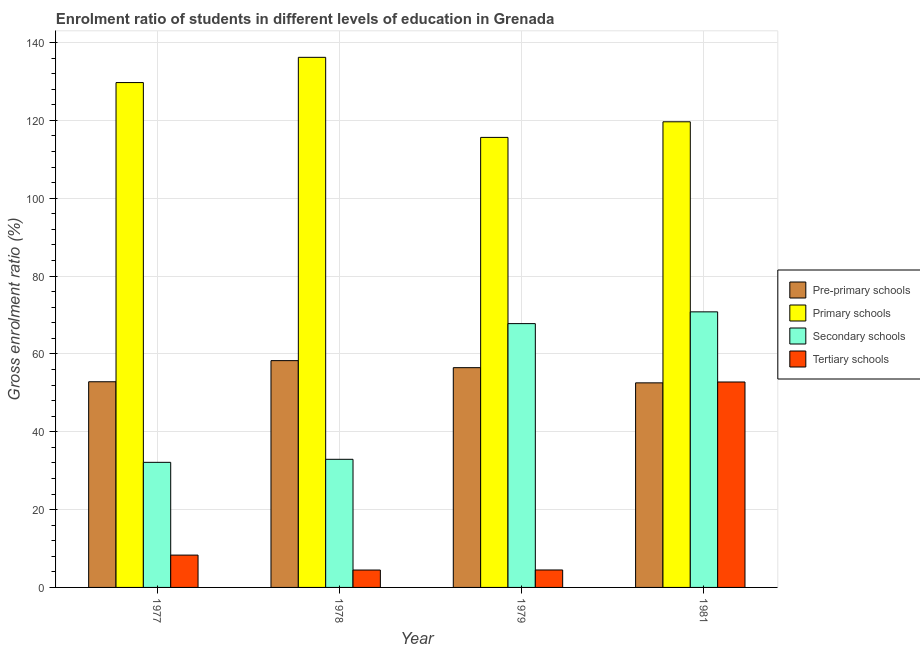Are the number of bars per tick equal to the number of legend labels?
Ensure brevity in your answer.  Yes. Are the number of bars on each tick of the X-axis equal?
Keep it short and to the point. Yes. What is the label of the 4th group of bars from the left?
Provide a succinct answer. 1981. What is the gross enrolment ratio in primary schools in 1981?
Ensure brevity in your answer.  119.62. Across all years, what is the maximum gross enrolment ratio in primary schools?
Provide a short and direct response. 136.18. Across all years, what is the minimum gross enrolment ratio in secondary schools?
Your response must be concise. 32.13. In which year was the gross enrolment ratio in primary schools maximum?
Provide a short and direct response. 1978. In which year was the gross enrolment ratio in primary schools minimum?
Your answer should be very brief. 1979. What is the total gross enrolment ratio in tertiary schools in the graph?
Offer a terse response. 70.02. What is the difference between the gross enrolment ratio in tertiary schools in 1978 and that in 1979?
Provide a short and direct response. -0.02. What is the difference between the gross enrolment ratio in primary schools in 1979 and the gross enrolment ratio in tertiary schools in 1981?
Your response must be concise. -4.01. What is the average gross enrolment ratio in primary schools per year?
Your answer should be compact. 125.27. In the year 1978, what is the difference between the gross enrolment ratio in tertiary schools and gross enrolment ratio in pre-primary schools?
Offer a terse response. 0. What is the ratio of the gross enrolment ratio in secondary schools in 1978 to that in 1979?
Make the answer very short. 0.49. Is the gross enrolment ratio in secondary schools in 1978 less than that in 1981?
Keep it short and to the point. Yes. Is the difference between the gross enrolment ratio in pre-primary schools in 1979 and 1981 greater than the difference between the gross enrolment ratio in primary schools in 1979 and 1981?
Provide a short and direct response. No. What is the difference between the highest and the second highest gross enrolment ratio in tertiary schools?
Your answer should be very brief. 44.47. What is the difference between the highest and the lowest gross enrolment ratio in tertiary schools?
Your answer should be compact. 48.31. Is the sum of the gross enrolment ratio in secondary schools in 1977 and 1981 greater than the maximum gross enrolment ratio in tertiary schools across all years?
Your answer should be compact. Yes. Is it the case that in every year, the sum of the gross enrolment ratio in tertiary schools and gross enrolment ratio in primary schools is greater than the sum of gross enrolment ratio in pre-primary schools and gross enrolment ratio in secondary schools?
Make the answer very short. No. What does the 3rd bar from the left in 1979 represents?
Provide a succinct answer. Secondary schools. What does the 3rd bar from the right in 1981 represents?
Provide a succinct answer. Primary schools. Are all the bars in the graph horizontal?
Offer a terse response. No. How many years are there in the graph?
Keep it short and to the point. 4. What is the difference between two consecutive major ticks on the Y-axis?
Offer a terse response. 20. Are the values on the major ticks of Y-axis written in scientific E-notation?
Offer a terse response. No. Does the graph contain grids?
Make the answer very short. Yes. Where does the legend appear in the graph?
Make the answer very short. Center right. What is the title of the graph?
Offer a very short reply. Enrolment ratio of students in different levels of education in Grenada. What is the label or title of the X-axis?
Give a very brief answer. Year. What is the Gross enrolment ratio (%) in Pre-primary schools in 1977?
Make the answer very short. 52.84. What is the Gross enrolment ratio (%) in Primary schools in 1977?
Offer a terse response. 129.69. What is the Gross enrolment ratio (%) of Secondary schools in 1977?
Make the answer very short. 32.13. What is the Gross enrolment ratio (%) of Tertiary schools in 1977?
Provide a short and direct response. 8.3. What is the Gross enrolment ratio (%) of Pre-primary schools in 1978?
Make the answer very short. 58.26. What is the Gross enrolment ratio (%) in Primary schools in 1978?
Offer a very short reply. 136.18. What is the Gross enrolment ratio (%) of Secondary schools in 1978?
Make the answer very short. 32.91. What is the Gross enrolment ratio (%) of Tertiary schools in 1978?
Your answer should be compact. 4.47. What is the Gross enrolment ratio (%) in Pre-primary schools in 1979?
Your answer should be very brief. 56.45. What is the Gross enrolment ratio (%) in Primary schools in 1979?
Your response must be concise. 115.61. What is the Gross enrolment ratio (%) of Secondary schools in 1979?
Your response must be concise. 67.77. What is the Gross enrolment ratio (%) of Tertiary schools in 1979?
Make the answer very short. 4.48. What is the Gross enrolment ratio (%) in Pre-primary schools in 1981?
Offer a very short reply. 52.55. What is the Gross enrolment ratio (%) in Primary schools in 1981?
Keep it short and to the point. 119.62. What is the Gross enrolment ratio (%) in Secondary schools in 1981?
Give a very brief answer. 70.79. What is the Gross enrolment ratio (%) of Tertiary schools in 1981?
Your answer should be very brief. 52.77. Across all years, what is the maximum Gross enrolment ratio (%) in Pre-primary schools?
Offer a very short reply. 58.26. Across all years, what is the maximum Gross enrolment ratio (%) in Primary schools?
Offer a very short reply. 136.18. Across all years, what is the maximum Gross enrolment ratio (%) in Secondary schools?
Your answer should be very brief. 70.79. Across all years, what is the maximum Gross enrolment ratio (%) in Tertiary schools?
Provide a succinct answer. 52.77. Across all years, what is the minimum Gross enrolment ratio (%) in Pre-primary schools?
Your response must be concise. 52.55. Across all years, what is the minimum Gross enrolment ratio (%) of Primary schools?
Ensure brevity in your answer.  115.61. Across all years, what is the minimum Gross enrolment ratio (%) of Secondary schools?
Keep it short and to the point. 32.13. Across all years, what is the minimum Gross enrolment ratio (%) of Tertiary schools?
Give a very brief answer. 4.47. What is the total Gross enrolment ratio (%) of Pre-primary schools in the graph?
Offer a terse response. 220.1. What is the total Gross enrolment ratio (%) of Primary schools in the graph?
Offer a terse response. 501.1. What is the total Gross enrolment ratio (%) in Secondary schools in the graph?
Give a very brief answer. 203.61. What is the total Gross enrolment ratio (%) in Tertiary schools in the graph?
Provide a short and direct response. 70.02. What is the difference between the Gross enrolment ratio (%) of Pre-primary schools in 1977 and that in 1978?
Give a very brief answer. -5.42. What is the difference between the Gross enrolment ratio (%) of Primary schools in 1977 and that in 1978?
Provide a short and direct response. -6.49. What is the difference between the Gross enrolment ratio (%) of Secondary schools in 1977 and that in 1978?
Offer a very short reply. -0.78. What is the difference between the Gross enrolment ratio (%) in Tertiary schools in 1977 and that in 1978?
Keep it short and to the point. 3.84. What is the difference between the Gross enrolment ratio (%) in Pre-primary schools in 1977 and that in 1979?
Make the answer very short. -3.62. What is the difference between the Gross enrolment ratio (%) in Primary schools in 1977 and that in 1979?
Your answer should be very brief. 14.08. What is the difference between the Gross enrolment ratio (%) of Secondary schools in 1977 and that in 1979?
Ensure brevity in your answer.  -35.63. What is the difference between the Gross enrolment ratio (%) in Tertiary schools in 1977 and that in 1979?
Ensure brevity in your answer.  3.82. What is the difference between the Gross enrolment ratio (%) of Pre-primary schools in 1977 and that in 1981?
Keep it short and to the point. 0.28. What is the difference between the Gross enrolment ratio (%) in Primary schools in 1977 and that in 1981?
Give a very brief answer. 10.07. What is the difference between the Gross enrolment ratio (%) in Secondary schools in 1977 and that in 1981?
Offer a very short reply. -38.66. What is the difference between the Gross enrolment ratio (%) of Tertiary schools in 1977 and that in 1981?
Your answer should be very brief. -44.47. What is the difference between the Gross enrolment ratio (%) of Pre-primary schools in 1978 and that in 1979?
Provide a short and direct response. 1.81. What is the difference between the Gross enrolment ratio (%) in Primary schools in 1978 and that in 1979?
Offer a very short reply. 20.57. What is the difference between the Gross enrolment ratio (%) in Secondary schools in 1978 and that in 1979?
Provide a short and direct response. -34.86. What is the difference between the Gross enrolment ratio (%) in Tertiary schools in 1978 and that in 1979?
Offer a very short reply. -0.02. What is the difference between the Gross enrolment ratio (%) of Pre-primary schools in 1978 and that in 1981?
Ensure brevity in your answer.  5.71. What is the difference between the Gross enrolment ratio (%) in Primary schools in 1978 and that in 1981?
Your answer should be compact. 16.56. What is the difference between the Gross enrolment ratio (%) of Secondary schools in 1978 and that in 1981?
Your answer should be compact. -37.88. What is the difference between the Gross enrolment ratio (%) in Tertiary schools in 1978 and that in 1981?
Make the answer very short. -48.31. What is the difference between the Gross enrolment ratio (%) of Primary schools in 1979 and that in 1981?
Give a very brief answer. -4.01. What is the difference between the Gross enrolment ratio (%) of Secondary schools in 1979 and that in 1981?
Offer a terse response. -3.02. What is the difference between the Gross enrolment ratio (%) of Tertiary schools in 1979 and that in 1981?
Give a very brief answer. -48.29. What is the difference between the Gross enrolment ratio (%) in Pre-primary schools in 1977 and the Gross enrolment ratio (%) in Primary schools in 1978?
Your answer should be very brief. -83.34. What is the difference between the Gross enrolment ratio (%) of Pre-primary schools in 1977 and the Gross enrolment ratio (%) of Secondary schools in 1978?
Your response must be concise. 19.92. What is the difference between the Gross enrolment ratio (%) of Pre-primary schools in 1977 and the Gross enrolment ratio (%) of Tertiary schools in 1978?
Keep it short and to the point. 48.37. What is the difference between the Gross enrolment ratio (%) of Primary schools in 1977 and the Gross enrolment ratio (%) of Secondary schools in 1978?
Provide a short and direct response. 96.78. What is the difference between the Gross enrolment ratio (%) in Primary schools in 1977 and the Gross enrolment ratio (%) in Tertiary schools in 1978?
Provide a succinct answer. 125.23. What is the difference between the Gross enrolment ratio (%) in Secondary schools in 1977 and the Gross enrolment ratio (%) in Tertiary schools in 1978?
Ensure brevity in your answer.  27.67. What is the difference between the Gross enrolment ratio (%) in Pre-primary schools in 1977 and the Gross enrolment ratio (%) in Primary schools in 1979?
Your response must be concise. -62.77. What is the difference between the Gross enrolment ratio (%) in Pre-primary schools in 1977 and the Gross enrolment ratio (%) in Secondary schools in 1979?
Provide a succinct answer. -14.93. What is the difference between the Gross enrolment ratio (%) in Pre-primary schools in 1977 and the Gross enrolment ratio (%) in Tertiary schools in 1979?
Ensure brevity in your answer.  48.35. What is the difference between the Gross enrolment ratio (%) in Primary schools in 1977 and the Gross enrolment ratio (%) in Secondary schools in 1979?
Provide a short and direct response. 61.92. What is the difference between the Gross enrolment ratio (%) of Primary schools in 1977 and the Gross enrolment ratio (%) of Tertiary schools in 1979?
Provide a short and direct response. 125.21. What is the difference between the Gross enrolment ratio (%) in Secondary schools in 1977 and the Gross enrolment ratio (%) in Tertiary schools in 1979?
Your response must be concise. 27.65. What is the difference between the Gross enrolment ratio (%) of Pre-primary schools in 1977 and the Gross enrolment ratio (%) of Primary schools in 1981?
Provide a succinct answer. -66.78. What is the difference between the Gross enrolment ratio (%) of Pre-primary schools in 1977 and the Gross enrolment ratio (%) of Secondary schools in 1981?
Your answer should be very brief. -17.96. What is the difference between the Gross enrolment ratio (%) in Pre-primary schools in 1977 and the Gross enrolment ratio (%) in Tertiary schools in 1981?
Make the answer very short. 0.06. What is the difference between the Gross enrolment ratio (%) in Primary schools in 1977 and the Gross enrolment ratio (%) in Secondary schools in 1981?
Your answer should be compact. 58.9. What is the difference between the Gross enrolment ratio (%) in Primary schools in 1977 and the Gross enrolment ratio (%) in Tertiary schools in 1981?
Keep it short and to the point. 76.92. What is the difference between the Gross enrolment ratio (%) of Secondary schools in 1977 and the Gross enrolment ratio (%) of Tertiary schools in 1981?
Offer a very short reply. -20.64. What is the difference between the Gross enrolment ratio (%) of Pre-primary schools in 1978 and the Gross enrolment ratio (%) of Primary schools in 1979?
Keep it short and to the point. -57.35. What is the difference between the Gross enrolment ratio (%) of Pre-primary schools in 1978 and the Gross enrolment ratio (%) of Secondary schools in 1979?
Your answer should be very brief. -9.51. What is the difference between the Gross enrolment ratio (%) of Pre-primary schools in 1978 and the Gross enrolment ratio (%) of Tertiary schools in 1979?
Your answer should be compact. 53.78. What is the difference between the Gross enrolment ratio (%) of Primary schools in 1978 and the Gross enrolment ratio (%) of Secondary schools in 1979?
Make the answer very short. 68.41. What is the difference between the Gross enrolment ratio (%) in Primary schools in 1978 and the Gross enrolment ratio (%) in Tertiary schools in 1979?
Your answer should be very brief. 131.69. What is the difference between the Gross enrolment ratio (%) in Secondary schools in 1978 and the Gross enrolment ratio (%) in Tertiary schools in 1979?
Make the answer very short. 28.43. What is the difference between the Gross enrolment ratio (%) of Pre-primary schools in 1978 and the Gross enrolment ratio (%) of Primary schools in 1981?
Your response must be concise. -61.36. What is the difference between the Gross enrolment ratio (%) in Pre-primary schools in 1978 and the Gross enrolment ratio (%) in Secondary schools in 1981?
Keep it short and to the point. -12.53. What is the difference between the Gross enrolment ratio (%) in Pre-primary schools in 1978 and the Gross enrolment ratio (%) in Tertiary schools in 1981?
Make the answer very short. 5.49. What is the difference between the Gross enrolment ratio (%) of Primary schools in 1978 and the Gross enrolment ratio (%) of Secondary schools in 1981?
Offer a very short reply. 65.39. What is the difference between the Gross enrolment ratio (%) of Primary schools in 1978 and the Gross enrolment ratio (%) of Tertiary schools in 1981?
Provide a succinct answer. 83.41. What is the difference between the Gross enrolment ratio (%) of Secondary schools in 1978 and the Gross enrolment ratio (%) of Tertiary schools in 1981?
Provide a short and direct response. -19.86. What is the difference between the Gross enrolment ratio (%) of Pre-primary schools in 1979 and the Gross enrolment ratio (%) of Primary schools in 1981?
Provide a succinct answer. -63.16. What is the difference between the Gross enrolment ratio (%) in Pre-primary schools in 1979 and the Gross enrolment ratio (%) in Secondary schools in 1981?
Provide a succinct answer. -14.34. What is the difference between the Gross enrolment ratio (%) of Pre-primary schools in 1979 and the Gross enrolment ratio (%) of Tertiary schools in 1981?
Your answer should be very brief. 3.68. What is the difference between the Gross enrolment ratio (%) in Primary schools in 1979 and the Gross enrolment ratio (%) in Secondary schools in 1981?
Provide a short and direct response. 44.82. What is the difference between the Gross enrolment ratio (%) of Primary schools in 1979 and the Gross enrolment ratio (%) of Tertiary schools in 1981?
Your response must be concise. 62.84. What is the difference between the Gross enrolment ratio (%) in Secondary schools in 1979 and the Gross enrolment ratio (%) in Tertiary schools in 1981?
Your answer should be very brief. 15. What is the average Gross enrolment ratio (%) in Pre-primary schools per year?
Give a very brief answer. 55.03. What is the average Gross enrolment ratio (%) of Primary schools per year?
Offer a terse response. 125.27. What is the average Gross enrolment ratio (%) of Secondary schools per year?
Your response must be concise. 50.9. What is the average Gross enrolment ratio (%) of Tertiary schools per year?
Offer a very short reply. 17.51. In the year 1977, what is the difference between the Gross enrolment ratio (%) in Pre-primary schools and Gross enrolment ratio (%) in Primary schools?
Offer a terse response. -76.86. In the year 1977, what is the difference between the Gross enrolment ratio (%) in Pre-primary schools and Gross enrolment ratio (%) in Secondary schools?
Make the answer very short. 20.7. In the year 1977, what is the difference between the Gross enrolment ratio (%) of Pre-primary schools and Gross enrolment ratio (%) of Tertiary schools?
Your answer should be very brief. 44.53. In the year 1977, what is the difference between the Gross enrolment ratio (%) of Primary schools and Gross enrolment ratio (%) of Secondary schools?
Keep it short and to the point. 97.56. In the year 1977, what is the difference between the Gross enrolment ratio (%) of Primary schools and Gross enrolment ratio (%) of Tertiary schools?
Your response must be concise. 121.39. In the year 1977, what is the difference between the Gross enrolment ratio (%) in Secondary schools and Gross enrolment ratio (%) in Tertiary schools?
Make the answer very short. 23.83. In the year 1978, what is the difference between the Gross enrolment ratio (%) of Pre-primary schools and Gross enrolment ratio (%) of Primary schools?
Offer a terse response. -77.92. In the year 1978, what is the difference between the Gross enrolment ratio (%) in Pre-primary schools and Gross enrolment ratio (%) in Secondary schools?
Your answer should be very brief. 25.35. In the year 1978, what is the difference between the Gross enrolment ratio (%) of Pre-primary schools and Gross enrolment ratio (%) of Tertiary schools?
Provide a succinct answer. 53.79. In the year 1978, what is the difference between the Gross enrolment ratio (%) of Primary schools and Gross enrolment ratio (%) of Secondary schools?
Keep it short and to the point. 103.27. In the year 1978, what is the difference between the Gross enrolment ratio (%) of Primary schools and Gross enrolment ratio (%) of Tertiary schools?
Your answer should be very brief. 131.71. In the year 1978, what is the difference between the Gross enrolment ratio (%) in Secondary schools and Gross enrolment ratio (%) in Tertiary schools?
Provide a short and direct response. 28.45. In the year 1979, what is the difference between the Gross enrolment ratio (%) in Pre-primary schools and Gross enrolment ratio (%) in Primary schools?
Your answer should be very brief. -59.15. In the year 1979, what is the difference between the Gross enrolment ratio (%) of Pre-primary schools and Gross enrolment ratio (%) of Secondary schools?
Provide a succinct answer. -11.32. In the year 1979, what is the difference between the Gross enrolment ratio (%) in Pre-primary schools and Gross enrolment ratio (%) in Tertiary schools?
Your answer should be very brief. 51.97. In the year 1979, what is the difference between the Gross enrolment ratio (%) of Primary schools and Gross enrolment ratio (%) of Secondary schools?
Ensure brevity in your answer.  47.84. In the year 1979, what is the difference between the Gross enrolment ratio (%) of Primary schools and Gross enrolment ratio (%) of Tertiary schools?
Your answer should be very brief. 111.13. In the year 1979, what is the difference between the Gross enrolment ratio (%) of Secondary schools and Gross enrolment ratio (%) of Tertiary schools?
Your answer should be compact. 63.29. In the year 1981, what is the difference between the Gross enrolment ratio (%) of Pre-primary schools and Gross enrolment ratio (%) of Primary schools?
Your answer should be very brief. -67.06. In the year 1981, what is the difference between the Gross enrolment ratio (%) of Pre-primary schools and Gross enrolment ratio (%) of Secondary schools?
Offer a very short reply. -18.24. In the year 1981, what is the difference between the Gross enrolment ratio (%) of Pre-primary schools and Gross enrolment ratio (%) of Tertiary schools?
Provide a short and direct response. -0.22. In the year 1981, what is the difference between the Gross enrolment ratio (%) of Primary schools and Gross enrolment ratio (%) of Secondary schools?
Offer a very short reply. 48.82. In the year 1981, what is the difference between the Gross enrolment ratio (%) of Primary schools and Gross enrolment ratio (%) of Tertiary schools?
Offer a terse response. 66.84. In the year 1981, what is the difference between the Gross enrolment ratio (%) of Secondary schools and Gross enrolment ratio (%) of Tertiary schools?
Give a very brief answer. 18.02. What is the ratio of the Gross enrolment ratio (%) of Pre-primary schools in 1977 to that in 1978?
Give a very brief answer. 0.91. What is the ratio of the Gross enrolment ratio (%) of Secondary schools in 1977 to that in 1978?
Provide a succinct answer. 0.98. What is the ratio of the Gross enrolment ratio (%) of Tertiary schools in 1977 to that in 1978?
Give a very brief answer. 1.86. What is the ratio of the Gross enrolment ratio (%) of Pre-primary schools in 1977 to that in 1979?
Give a very brief answer. 0.94. What is the ratio of the Gross enrolment ratio (%) of Primary schools in 1977 to that in 1979?
Keep it short and to the point. 1.12. What is the ratio of the Gross enrolment ratio (%) in Secondary schools in 1977 to that in 1979?
Keep it short and to the point. 0.47. What is the ratio of the Gross enrolment ratio (%) in Tertiary schools in 1977 to that in 1979?
Keep it short and to the point. 1.85. What is the ratio of the Gross enrolment ratio (%) of Pre-primary schools in 1977 to that in 1981?
Your answer should be very brief. 1.01. What is the ratio of the Gross enrolment ratio (%) of Primary schools in 1977 to that in 1981?
Ensure brevity in your answer.  1.08. What is the ratio of the Gross enrolment ratio (%) of Secondary schools in 1977 to that in 1981?
Your answer should be compact. 0.45. What is the ratio of the Gross enrolment ratio (%) of Tertiary schools in 1977 to that in 1981?
Give a very brief answer. 0.16. What is the ratio of the Gross enrolment ratio (%) in Pre-primary schools in 1978 to that in 1979?
Your answer should be compact. 1.03. What is the ratio of the Gross enrolment ratio (%) in Primary schools in 1978 to that in 1979?
Your answer should be compact. 1.18. What is the ratio of the Gross enrolment ratio (%) of Secondary schools in 1978 to that in 1979?
Keep it short and to the point. 0.49. What is the ratio of the Gross enrolment ratio (%) of Tertiary schools in 1978 to that in 1979?
Give a very brief answer. 1. What is the ratio of the Gross enrolment ratio (%) of Pre-primary schools in 1978 to that in 1981?
Keep it short and to the point. 1.11. What is the ratio of the Gross enrolment ratio (%) in Primary schools in 1978 to that in 1981?
Offer a terse response. 1.14. What is the ratio of the Gross enrolment ratio (%) in Secondary schools in 1978 to that in 1981?
Ensure brevity in your answer.  0.46. What is the ratio of the Gross enrolment ratio (%) in Tertiary schools in 1978 to that in 1981?
Your answer should be very brief. 0.08. What is the ratio of the Gross enrolment ratio (%) of Pre-primary schools in 1979 to that in 1981?
Offer a terse response. 1.07. What is the ratio of the Gross enrolment ratio (%) of Primary schools in 1979 to that in 1981?
Ensure brevity in your answer.  0.97. What is the ratio of the Gross enrolment ratio (%) in Secondary schools in 1979 to that in 1981?
Provide a short and direct response. 0.96. What is the ratio of the Gross enrolment ratio (%) in Tertiary schools in 1979 to that in 1981?
Offer a terse response. 0.09. What is the difference between the highest and the second highest Gross enrolment ratio (%) in Pre-primary schools?
Keep it short and to the point. 1.81. What is the difference between the highest and the second highest Gross enrolment ratio (%) in Primary schools?
Make the answer very short. 6.49. What is the difference between the highest and the second highest Gross enrolment ratio (%) of Secondary schools?
Give a very brief answer. 3.02. What is the difference between the highest and the second highest Gross enrolment ratio (%) in Tertiary schools?
Give a very brief answer. 44.47. What is the difference between the highest and the lowest Gross enrolment ratio (%) in Pre-primary schools?
Provide a short and direct response. 5.71. What is the difference between the highest and the lowest Gross enrolment ratio (%) of Primary schools?
Your answer should be very brief. 20.57. What is the difference between the highest and the lowest Gross enrolment ratio (%) in Secondary schools?
Ensure brevity in your answer.  38.66. What is the difference between the highest and the lowest Gross enrolment ratio (%) of Tertiary schools?
Give a very brief answer. 48.31. 